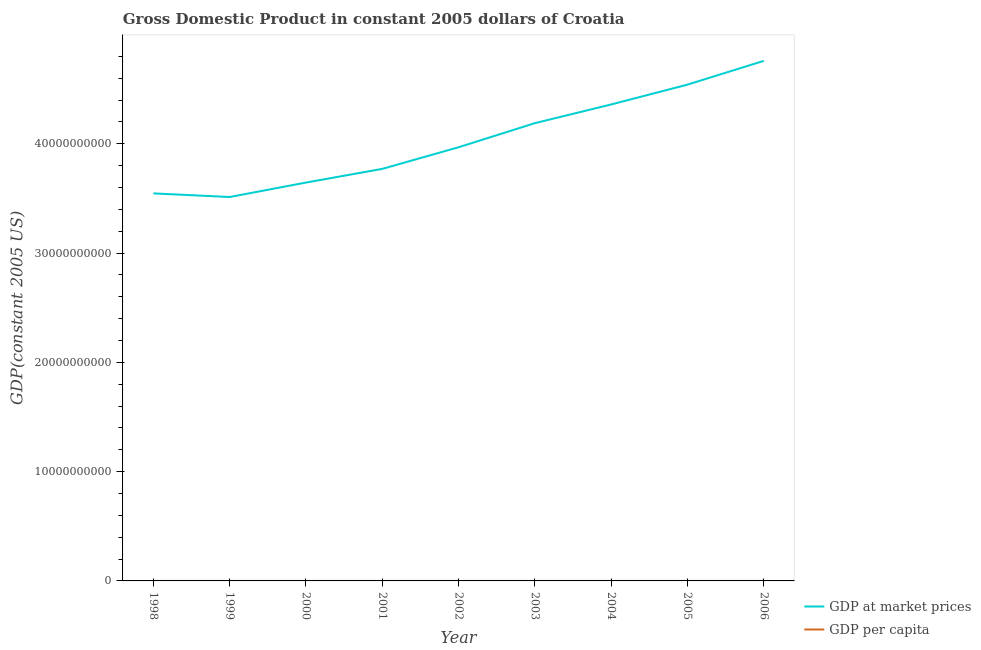What is the gdp per capita in 1999?
Your answer should be compact. 7714.29. Across all years, what is the maximum gdp at market prices?
Your answer should be very brief. 4.76e+1. Across all years, what is the minimum gdp per capita?
Your response must be concise. 7714.29. In which year was the gdp at market prices maximum?
Provide a succinct answer. 2006. What is the total gdp at market prices in the graph?
Ensure brevity in your answer.  3.63e+11. What is the difference between the gdp at market prices in 1998 and that in 2006?
Offer a terse response. -1.21e+1. What is the difference between the gdp at market prices in 2003 and the gdp per capita in 2005?
Your answer should be very brief. 4.19e+1. What is the average gdp at market prices per year?
Offer a terse response. 4.03e+1. In the year 1998, what is the difference between the gdp at market prices and gdp per capita?
Your response must be concise. 3.55e+1. What is the ratio of the gdp per capita in 2002 to that in 2005?
Provide a short and direct response. 0.87. Is the gdp per capita in 1998 less than that in 1999?
Keep it short and to the point. No. What is the difference between the highest and the second highest gdp per capita?
Give a very brief answer. 494.07. What is the difference between the highest and the lowest gdp at market prices?
Your answer should be very brief. 1.25e+1. In how many years, is the gdp at market prices greater than the average gdp at market prices taken over all years?
Make the answer very short. 4. Is the gdp per capita strictly greater than the gdp at market prices over the years?
Offer a very short reply. No. Is the gdp per capita strictly less than the gdp at market prices over the years?
Ensure brevity in your answer.  Yes. What is the difference between two consecutive major ticks on the Y-axis?
Your response must be concise. 1.00e+1. Are the values on the major ticks of Y-axis written in scientific E-notation?
Make the answer very short. No. Where does the legend appear in the graph?
Make the answer very short. Bottom right. What is the title of the graph?
Keep it short and to the point. Gross Domestic Product in constant 2005 dollars of Croatia. Does "Forest" appear as one of the legend labels in the graph?
Your response must be concise. No. What is the label or title of the X-axis?
Provide a short and direct response. Year. What is the label or title of the Y-axis?
Ensure brevity in your answer.  GDP(constant 2005 US). What is the GDP(constant 2005 US) in GDP at market prices in 1998?
Your answer should be compact. 3.55e+1. What is the GDP(constant 2005 US) of GDP per capita in 1998?
Give a very brief answer. 7878.83. What is the GDP(constant 2005 US) of GDP at market prices in 1999?
Offer a terse response. 3.51e+1. What is the GDP(constant 2005 US) of GDP per capita in 1999?
Your response must be concise. 7714.29. What is the GDP(constant 2005 US) of GDP at market prices in 2000?
Provide a short and direct response. 3.65e+1. What is the GDP(constant 2005 US) in GDP per capita in 2000?
Your answer should be compact. 8236.43. What is the GDP(constant 2005 US) in GDP at market prices in 2001?
Provide a short and direct response. 3.77e+1. What is the GDP(constant 2005 US) of GDP per capita in 2001?
Offer a very short reply. 8492.44. What is the GDP(constant 2005 US) of GDP at market prices in 2002?
Your answer should be very brief. 3.97e+1. What is the GDP(constant 2005 US) in GDP per capita in 2002?
Provide a short and direct response. 8937.99. What is the GDP(constant 2005 US) in GDP at market prices in 2003?
Provide a short and direct response. 4.19e+1. What is the GDP(constant 2005 US) of GDP per capita in 2003?
Make the answer very short. 9434.76. What is the GDP(constant 2005 US) in GDP at market prices in 2004?
Your answer should be very brief. 4.36e+1. What is the GDP(constant 2005 US) in GDP per capita in 2004?
Offer a terse response. 9822.17. What is the GDP(constant 2005 US) in GDP at market prices in 2005?
Offer a terse response. 4.54e+1. What is the GDP(constant 2005 US) in GDP per capita in 2005?
Offer a very short reply. 1.02e+04. What is the GDP(constant 2005 US) of GDP at market prices in 2006?
Your answer should be compact. 4.76e+1. What is the GDP(constant 2005 US) of GDP per capita in 2006?
Your answer should be compact. 1.07e+04. Across all years, what is the maximum GDP(constant 2005 US) in GDP at market prices?
Ensure brevity in your answer.  4.76e+1. Across all years, what is the maximum GDP(constant 2005 US) of GDP per capita?
Offer a very short reply. 1.07e+04. Across all years, what is the minimum GDP(constant 2005 US) of GDP at market prices?
Offer a terse response. 3.51e+1. Across all years, what is the minimum GDP(constant 2005 US) in GDP per capita?
Provide a succinct answer. 7714.29. What is the total GDP(constant 2005 US) of GDP at market prices in the graph?
Your response must be concise. 3.63e+11. What is the total GDP(constant 2005 US) of GDP per capita in the graph?
Offer a very short reply. 8.15e+04. What is the difference between the GDP(constant 2005 US) in GDP at market prices in 1998 and that in 1999?
Offer a very short reply. 3.32e+08. What is the difference between the GDP(constant 2005 US) of GDP per capita in 1998 and that in 1999?
Your response must be concise. 164.54. What is the difference between the GDP(constant 2005 US) in GDP at market prices in 1998 and that in 2000?
Offer a very short reply. -9.92e+08. What is the difference between the GDP(constant 2005 US) of GDP per capita in 1998 and that in 2000?
Your answer should be compact. -357.59. What is the difference between the GDP(constant 2005 US) in GDP at market prices in 1998 and that in 2001?
Your answer should be very brief. -2.24e+09. What is the difference between the GDP(constant 2005 US) of GDP per capita in 1998 and that in 2001?
Offer a terse response. -613.6. What is the difference between the GDP(constant 2005 US) in GDP at market prices in 1998 and that in 2002?
Offer a very short reply. -4.22e+09. What is the difference between the GDP(constant 2005 US) of GDP per capita in 1998 and that in 2002?
Your answer should be very brief. -1059.16. What is the difference between the GDP(constant 2005 US) of GDP at market prices in 1998 and that in 2003?
Keep it short and to the point. -6.43e+09. What is the difference between the GDP(constant 2005 US) in GDP per capita in 1998 and that in 2003?
Your answer should be compact. -1555.92. What is the difference between the GDP(constant 2005 US) in GDP at market prices in 1998 and that in 2004?
Offer a terse response. -8.14e+09. What is the difference between the GDP(constant 2005 US) in GDP per capita in 1998 and that in 2004?
Ensure brevity in your answer.  -1943.34. What is the difference between the GDP(constant 2005 US) in GDP at market prices in 1998 and that in 2005?
Offer a very short reply. -9.95e+09. What is the difference between the GDP(constant 2005 US) in GDP per capita in 1998 and that in 2005?
Your answer should be very brief. -2345.41. What is the difference between the GDP(constant 2005 US) in GDP at market prices in 1998 and that in 2006?
Offer a very short reply. -1.21e+1. What is the difference between the GDP(constant 2005 US) of GDP per capita in 1998 and that in 2006?
Your answer should be compact. -2839.48. What is the difference between the GDP(constant 2005 US) of GDP at market prices in 1999 and that in 2000?
Provide a short and direct response. -1.32e+09. What is the difference between the GDP(constant 2005 US) of GDP per capita in 1999 and that in 2000?
Provide a short and direct response. -522.14. What is the difference between the GDP(constant 2005 US) in GDP at market prices in 1999 and that in 2001?
Your answer should be compact. -2.58e+09. What is the difference between the GDP(constant 2005 US) of GDP per capita in 1999 and that in 2001?
Ensure brevity in your answer.  -778.15. What is the difference between the GDP(constant 2005 US) in GDP at market prices in 1999 and that in 2002?
Your answer should be very brief. -4.55e+09. What is the difference between the GDP(constant 2005 US) in GDP per capita in 1999 and that in 2002?
Your response must be concise. -1223.7. What is the difference between the GDP(constant 2005 US) of GDP at market prices in 1999 and that in 2003?
Keep it short and to the point. -6.76e+09. What is the difference between the GDP(constant 2005 US) in GDP per capita in 1999 and that in 2003?
Your answer should be compact. -1720.47. What is the difference between the GDP(constant 2005 US) in GDP at market prices in 1999 and that in 2004?
Make the answer very short. -8.47e+09. What is the difference between the GDP(constant 2005 US) of GDP per capita in 1999 and that in 2004?
Keep it short and to the point. -2107.88. What is the difference between the GDP(constant 2005 US) of GDP at market prices in 1999 and that in 2005?
Provide a short and direct response. -1.03e+1. What is the difference between the GDP(constant 2005 US) in GDP per capita in 1999 and that in 2005?
Your response must be concise. -2509.95. What is the difference between the GDP(constant 2005 US) in GDP at market prices in 1999 and that in 2006?
Your answer should be compact. -1.25e+1. What is the difference between the GDP(constant 2005 US) in GDP per capita in 1999 and that in 2006?
Ensure brevity in your answer.  -3004.02. What is the difference between the GDP(constant 2005 US) in GDP at market prices in 2000 and that in 2001?
Your answer should be very brief. -1.25e+09. What is the difference between the GDP(constant 2005 US) in GDP per capita in 2000 and that in 2001?
Provide a succinct answer. -256.01. What is the difference between the GDP(constant 2005 US) in GDP at market prices in 2000 and that in 2002?
Your response must be concise. -3.23e+09. What is the difference between the GDP(constant 2005 US) of GDP per capita in 2000 and that in 2002?
Keep it short and to the point. -701.56. What is the difference between the GDP(constant 2005 US) in GDP at market prices in 2000 and that in 2003?
Provide a succinct answer. -5.44e+09. What is the difference between the GDP(constant 2005 US) of GDP per capita in 2000 and that in 2003?
Your answer should be compact. -1198.33. What is the difference between the GDP(constant 2005 US) in GDP at market prices in 2000 and that in 2004?
Offer a terse response. -7.15e+09. What is the difference between the GDP(constant 2005 US) of GDP per capita in 2000 and that in 2004?
Keep it short and to the point. -1585.74. What is the difference between the GDP(constant 2005 US) in GDP at market prices in 2000 and that in 2005?
Give a very brief answer. -8.96e+09. What is the difference between the GDP(constant 2005 US) in GDP per capita in 2000 and that in 2005?
Give a very brief answer. -1987.81. What is the difference between the GDP(constant 2005 US) of GDP at market prices in 2000 and that in 2006?
Ensure brevity in your answer.  -1.11e+1. What is the difference between the GDP(constant 2005 US) in GDP per capita in 2000 and that in 2006?
Provide a succinct answer. -2481.88. What is the difference between the GDP(constant 2005 US) of GDP at market prices in 2001 and that in 2002?
Offer a terse response. -1.98e+09. What is the difference between the GDP(constant 2005 US) of GDP per capita in 2001 and that in 2002?
Provide a succinct answer. -445.55. What is the difference between the GDP(constant 2005 US) of GDP at market prices in 2001 and that in 2003?
Provide a short and direct response. -4.18e+09. What is the difference between the GDP(constant 2005 US) in GDP per capita in 2001 and that in 2003?
Your answer should be very brief. -942.32. What is the difference between the GDP(constant 2005 US) of GDP at market prices in 2001 and that in 2004?
Ensure brevity in your answer.  -5.89e+09. What is the difference between the GDP(constant 2005 US) of GDP per capita in 2001 and that in 2004?
Make the answer very short. -1329.73. What is the difference between the GDP(constant 2005 US) of GDP at market prices in 2001 and that in 2005?
Ensure brevity in your answer.  -7.71e+09. What is the difference between the GDP(constant 2005 US) of GDP per capita in 2001 and that in 2005?
Provide a succinct answer. -1731.8. What is the difference between the GDP(constant 2005 US) in GDP at market prices in 2001 and that in 2006?
Provide a short and direct response. -9.88e+09. What is the difference between the GDP(constant 2005 US) in GDP per capita in 2001 and that in 2006?
Provide a succinct answer. -2225.87. What is the difference between the GDP(constant 2005 US) of GDP at market prices in 2002 and that in 2003?
Ensure brevity in your answer.  -2.21e+09. What is the difference between the GDP(constant 2005 US) in GDP per capita in 2002 and that in 2003?
Provide a short and direct response. -496.77. What is the difference between the GDP(constant 2005 US) of GDP at market prices in 2002 and that in 2004?
Your response must be concise. -3.92e+09. What is the difference between the GDP(constant 2005 US) of GDP per capita in 2002 and that in 2004?
Provide a short and direct response. -884.18. What is the difference between the GDP(constant 2005 US) in GDP at market prices in 2002 and that in 2005?
Your answer should be compact. -5.73e+09. What is the difference between the GDP(constant 2005 US) in GDP per capita in 2002 and that in 2005?
Ensure brevity in your answer.  -1286.25. What is the difference between the GDP(constant 2005 US) of GDP at market prices in 2002 and that in 2006?
Your answer should be very brief. -7.90e+09. What is the difference between the GDP(constant 2005 US) in GDP per capita in 2002 and that in 2006?
Your response must be concise. -1780.32. What is the difference between the GDP(constant 2005 US) in GDP at market prices in 2003 and that in 2004?
Your answer should be very brief. -1.71e+09. What is the difference between the GDP(constant 2005 US) in GDP per capita in 2003 and that in 2004?
Your response must be concise. -387.42. What is the difference between the GDP(constant 2005 US) in GDP at market prices in 2003 and that in 2005?
Make the answer very short. -3.53e+09. What is the difference between the GDP(constant 2005 US) of GDP per capita in 2003 and that in 2005?
Your answer should be compact. -789.49. What is the difference between the GDP(constant 2005 US) of GDP at market prices in 2003 and that in 2006?
Make the answer very short. -5.70e+09. What is the difference between the GDP(constant 2005 US) in GDP per capita in 2003 and that in 2006?
Your answer should be compact. -1283.55. What is the difference between the GDP(constant 2005 US) of GDP at market prices in 2004 and that in 2005?
Your response must be concise. -1.82e+09. What is the difference between the GDP(constant 2005 US) of GDP per capita in 2004 and that in 2005?
Provide a short and direct response. -402.07. What is the difference between the GDP(constant 2005 US) in GDP at market prices in 2004 and that in 2006?
Your answer should be very brief. -3.99e+09. What is the difference between the GDP(constant 2005 US) in GDP per capita in 2004 and that in 2006?
Provide a short and direct response. -896.14. What is the difference between the GDP(constant 2005 US) of GDP at market prices in 2005 and that in 2006?
Your response must be concise. -2.17e+09. What is the difference between the GDP(constant 2005 US) in GDP per capita in 2005 and that in 2006?
Your response must be concise. -494.07. What is the difference between the GDP(constant 2005 US) of GDP at market prices in 1998 and the GDP(constant 2005 US) of GDP per capita in 1999?
Offer a very short reply. 3.55e+1. What is the difference between the GDP(constant 2005 US) of GDP at market prices in 1998 and the GDP(constant 2005 US) of GDP per capita in 2000?
Offer a very short reply. 3.55e+1. What is the difference between the GDP(constant 2005 US) of GDP at market prices in 1998 and the GDP(constant 2005 US) of GDP per capita in 2001?
Your answer should be compact. 3.55e+1. What is the difference between the GDP(constant 2005 US) in GDP at market prices in 1998 and the GDP(constant 2005 US) in GDP per capita in 2002?
Give a very brief answer. 3.55e+1. What is the difference between the GDP(constant 2005 US) of GDP at market prices in 1998 and the GDP(constant 2005 US) of GDP per capita in 2003?
Offer a very short reply. 3.55e+1. What is the difference between the GDP(constant 2005 US) of GDP at market prices in 1998 and the GDP(constant 2005 US) of GDP per capita in 2004?
Offer a very short reply. 3.55e+1. What is the difference between the GDP(constant 2005 US) in GDP at market prices in 1998 and the GDP(constant 2005 US) in GDP per capita in 2005?
Offer a very short reply. 3.55e+1. What is the difference between the GDP(constant 2005 US) in GDP at market prices in 1998 and the GDP(constant 2005 US) in GDP per capita in 2006?
Your answer should be compact. 3.55e+1. What is the difference between the GDP(constant 2005 US) in GDP at market prices in 1999 and the GDP(constant 2005 US) in GDP per capita in 2000?
Provide a succinct answer. 3.51e+1. What is the difference between the GDP(constant 2005 US) of GDP at market prices in 1999 and the GDP(constant 2005 US) of GDP per capita in 2001?
Your response must be concise. 3.51e+1. What is the difference between the GDP(constant 2005 US) in GDP at market prices in 1999 and the GDP(constant 2005 US) in GDP per capita in 2002?
Offer a very short reply. 3.51e+1. What is the difference between the GDP(constant 2005 US) in GDP at market prices in 1999 and the GDP(constant 2005 US) in GDP per capita in 2003?
Give a very brief answer. 3.51e+1. What is the difference between the GDP(constant 2005 US) in GDP at market prices in 1999 and the GDP(constant 2005 US) in GDP per capita in 2004?
Offer a terse response. 3.51e+1. What is the difference between the GDP(constant 2005 US) of GDP at market prices in 1999 and the GDP(constant 2005 US) of GDP per capita in 2005?
Provide a short and direct response. 3.51e+1. What is the difference between the GDP(constant 2005 US) of GDP at market prices in 1999 and the GDP(constant 2005 US) of GDP per capita in 2006?
Make the answer very short. 3.51e+1. What is the difference between the GDP(constant 2005 US) in GDP at market prices in 2000 and the GDP(constant 2005 US) in GDP per capita in 2001?
Provide a short and direct response. 3.65e+1. What is the difference between the GDP(constant 2005 US) in GDP at market prices in 2000 and the GDP(constant 2005 US) in GDP per capita in 2002?
Ensure brevity in your answer.  3.65e+1. What is the difference between the GDP(constant 2005 US) in GDP at market prices in 2000 and the GDP(constant 2005 US) in GDP per capita in 2003?
Provide a succinct answer. 3.65e+1. What is the difference between the GDP(constant 2005 US) of GDP at market prices in 2000 and the GDP(constant 2005 US) of GDP per capita in 2004?
Keep it short and to the point. 3.65e+1. What is the difference between the GDP(constant 2005 US) in GDP at market prices in 2000 and the GDP(constant 2005 US) in GDP per capita in 2005?
Make the answer very short. 3.65e+1. What is the difference between the GDP(constant 2005 US) of GDP at market prices in 2000 and the GDP(constant 2005 US) of GDP per capita in 2006?
Give a very brief answer. 3.65e+1. What is the difference between the GDP(constant 2005 US) of GDP at market prices in 2001 and the GDP(constant 2005 US) of GDP per capita in 2002?
Your answer should be compact. 3.77e+1. What is the difference between the GDP(constant 2005 US) in GDP at market prices in 2001 and the GDP(constant 2005 US) in GDP per capita in 2003?
Your answer should be compact. 3.77e+1. What is the difference between the GDP(constant 2005 US) of GDP at market prices in 2001 and the GDP(constant 2005 US) of GDP per capita in 2004?
Your response must be concise. 3.77e+1. What is the difference between the GDP(constant 2005 US) of GDP at market prices in 2001 and the GDP(constant 2005 US) of GDP per capita in 2005?
Keep it short and to the point. 3.77e+1. What is the difference between the GDP(constant 2005 US) in GDP at market prices in 2001 and the GDP(constant 2005 US) in GDP per capita in 2006?
Keep it short and to the point. 3.77e+1. What is the difference between the GDP(constant 2005 US) in GDP at market prices in 2002 and the GDP(constant 2005 US) in GDP per capita in 2003?
Offer a terse response. 3.97e+1. What is the difference between the GDP(constant 2005 US) in GDP at market prices in 2002 and the GDP(constant 2005 US) in GDP per capita in 2004?
Your answer should be compact. 3.97e+1. What is the difference between the GDP(constant 2005 US) in GDP at market prices in 2002 and the GDP(constant 2005 US) in GDP per capita in 2005?
Provide a short and direct response. 3.97e+1. What is the difference between the GDP(constant 2005 US) in GDP at market prices in 2002 and the GDP(constant 2005 US) in GDP per capita in 2006?
Make the answer very short. 3.97e+1. What is the difference between the GDP(constant 2005 US) in GDP at market prices in 2003 and the GDP(constant 2005 US) in GDP per capita in 2004?
Provide a succinct answer. 4.19e+1. What is the difference between the GDP(constant 2005 US) of GDP at market prices in 2003 and the GDP(constant 2005 US) of GDP per capita in 2005?
Offer a very short reply. 4.19e+1. What is the difference between the GDP(constant 2005 US) in GDP at market prices in 2003 and the GDP(constant 2005 US) in GDP per capita in 2006?
Give a very brief answer. 4.19e+1. What is the difference between the GDP(constant 2005 US) in GDP at market prices in 2004 and the GDP(constant 2005 US) in GDP per capita in 2005?
Offer a terse response. 4.36e+1. What is the difference between the GDP(constant 2005 US) in GDP at market prices in 2004 and the GDP(constant 2005 US) in GDP per capita in 2006?
Your answer should be very brief. 4.36e+1. What is the difference between the GDP(constant 2005 US) of GDP at market prices in 2005 and the GDP(constant 2005 US) of GDP per capita in 2006?
Make the answer very short. 4.54e+1. What is the average GDP(constant 2005 US) of GDP at market prices per year?
Offer a very short reply. 4.03e+1. What is the average GDP(constant 2005 US) of GDP per capita per year?
Make the answer very short. 9051.05. In the year 1998, what is the difference between the GDP(constant 2005 US) of GDP at market prices and GDP(constant 2005 US) of GDP per capita?
Make the answer very short. 3.55e+1. In the year 1999, what is the difference between the GDP(constant 2005 US) of GDP at market prices and GDP(constant 2005 US) of GDP per capita?
Your response must be concise. 3.51e+1. In the year 2000, what is the difference between the GDP(constant 2005 US) in GDP at market prices and GDP(constant 2005 US) in GDP per capita?
Offer a very short reply. 3.65e+1. In the year 2001, what is the difference between the GDP(constant 2005 US) of GDP at market prices and GDP(constant 2005 US) of GDP per capita?
Ensure brevity in your answer.  3.77e+1. In the year 2002, what is the difference between the GDP(constant 2005 US) of GDP at market prices and GDP(constant 2005 US) of GDP per capita?
Your answer should be very brief. 3.97e+1. In the year 2003, what is the difference between the GDP(constant 2005 US) of GDP at market prices and GDP(constant 2005 US) of GDP per capita?
Your answer should be very brief. 4.19e+1. In the year 2004, what is the difference between the GDP(constant 2005 US) in GDP at market prices and GDP(constant 2005 US) in GDP per capita?
Your answer should be compact. 4.36e+1. In the year 2005, what is the difference between the GDP(constant 2005 US) of GDP at market prices and GDP(constant 2005 US) of GDP per capita?
Make the answer very short. 4.54e+1. In the year 2006, what is the difference between the GDP(constant 2005 US) of GDP at market prices and GDP(constant 2005 US) of GDP per capita?
Keep it short and to the point. 4.76e+1. What is the ratio of the GDP(constant 2005 US) in GDP at market prices in 1998 to that in 1999?
Keep it short and to the point. 1.01. What is the ratio of the GDP(constant 2005 US) in GDP per capita in 1998 to that in 1999?
Provide a short and direct response. 1.02. What is the ratio of the GDP(constant 2005 US) of GDP at market prices in 1998 to that in 2000?
Provide a succinct answer. 0.97. What is the ratio of the GDP(constant 2005 US) of GDP per capita in 1998 to that in 2000?
Make the answer very short. 0.96. What is the ratio of the GDP(constant 2005 US) of GDP at market prices in 1998 to that in 2001?
Offer a very short reply. 0.94. What is the ratio of the GDP(constant 2005 US) in GDP per capita in 1998 to that in 2001?
Your answer should be compact. 0.93. What is the ratio of the GDP(constant 2005 US) of GDP at market prices in 1998 to that in 2002?
Keep it short and to the point. 0.89. What is the ratio of the GDP(constant 2005 US) in GDP per capita in 1998 to that in 2002?
Make the answer very short. 0.88. What is the ratio of the GDP(constant 2005 US) of GDP at market prices in 1998 to that in 2003?
Offer a terse response. 0.85. What is the ratio of the GDP(constant 2005 US) of GDP per capita in 1998 to that in 2003?
Ensure brevity in your answer.  0.84. What is the ratio of the GDP(constant 2005 US) of GDP at market prices in 1998 to that in 2004?
Ensure brevity in your answer.  0.81. What is the ratio of the GDP(constant 2005 US) in GDP per capita in 1998 to that in 2004?
Offer a terse response. 0.8. What is the ratio of the GDP(constant 2005 US) in GDP at market prices in 1998 to that in 2005?
Give a very brief answer. 0.78. What is the ratio of the GDP(constant 2005 US) of GDP per capita in 1998 to that in 2005?
Make the answer very short. 0.77. What is the ratio of the GDP(constant 2005 US) in GDP at market prices in 1998 to that in 2006?
Offer a terse response. 0.75. What is the ratio of the GDP(constant 2005 US) in GDP per capita in 1998 to that in 2006?
Provide a succinct answer. 0.74. What is the ratio of the GDP(constant 2005 US) in GDP at market prices in 1999 to that in 2000?
Your answer should be very brief. 0.96. What is the ratio of the GDP(constant 2005 US) in GDP per capita in 1999 to that in 2000?
Ensure brevity in your answer.  0.94. What is the ratio of the GDP(constant 2005 US) of GDP at market prices in 1999 to that in 2001?
Provide a short and direct response. 0.93. What is the ratio of the GDP(constant 2005 US) in GDP per capita in 1999 to that in 2001?
Provide a succinct answer. 0.91. What is the ratio of the GDP(constant 2005 US) in GDP at market prices in 1999 to that in 2002?
Provide a succinct answer. 0.89. What is the ratio of the GDP(constant 2005 US) in GDP per capita in 1999 to that in 2002?
Make the answer very short. 0.86. What is the ratio of the GDP(constant 2005 US) in GDP at market prices in 1999 to that in 2003?
Offer a terse response. 0.84. What is the ratio of the GDP(constant 2005 US) in GDP per capita in 1999 to that in 2003?
Make the answer very short. 0.82. What is the ratio of the GDP(constant 2005 US) in GDP at market prices in 1999 to that in 2004?
Offer a very short reply. 0.81. What is the ratio of the GDP(constant 2005 US) of GDP per capita in 1999 to that in 2004?
Your answer should be compact. 0.79. What is the ratio of the GDP(constant 2005 US) in GDP at market prices in 1999 to that in 2005?
Your answer should be very brief. 0.77. What is the ratio of the GDP(constant 2005 US) of GDP per capita in 1999 to that in 2005?
Provide a succinct answer. 0.75. What is the ratio of the GDP(constant 2005 US) in GDP at market prices in 1999 to that in 2006?
Offer a very short reply. 0.74. What is the ratio of the GDP(constant 2005 US) of GDP per capita in 1999 to that in 2006?
Keep it short and to the point. 0.72. What is the ratio of the GDP(constant 2005 US) in GDP at market prices in 2000 to that in 2001?
Offer a terse response. 0.97. What is the ratio of the GDP(constant 2005 US) of GDP per capita in 2000 to that in 2001?
Offer a very short reply. 0.97. What is the ratio of the GDP(constant 2005 US) in GDP at market prices in 2000 to that in 2002?
Your answer should be compact. 0.92. What is the ratio of the GDP(constant 2005 US) in GDP per capita in 2000 to that in 2002?
Your response must be concise. 0.92. What is the ratio of the GDP(constant 2005 US) of GDP at market prices in 2000 to that in 2003?
Your answer should be compact. 0.87. What is the ratio of the GDP(constant 2005 US) of GDP per capita in 2000 to that in 2003?
Your answer should be compact. 0.87. What is the ratio of the GDP(constant 2005 US) in GDP at market prices in 2000 to that in 2004?
Your response must be concise. 0.84. What is the ratio of the GDP(constant 2005 US) of GDP per capita in 2000 to that in 2004?
Your answer should be very brief. 0.84. What is the ratio of the GDP(constant 2005 US) of GDP at market prices in 2000 to that in 2005?
Your response must be concise. 0.8. What is the ratio of the GDP(constant 2005 US) of GDP per capita in 2000 to that in 2005?
Keep it short and to the point. 0.81. What is the ratio of the GDP(constant 2005 US) of GDP at market prices in 2000 to that in 2006?
Make the answer very short. 0.77. What is the ratio of the GDP(constant 2005 US) in GDP per capita in 2000 to that in 2006?
Offer a terse response. 0.77. What is the ratio of the GDP(constant 2005 US) in GDP at market prices in 2001 to that in 2002?
Offer a terse response. 0.95. What is the ratio of the GDP(constant 2005 US) of GDP per capita in 2001 to that in 2002?
Offer a terse response. 0.95. What is the ratio of the GDP(constant 2005 US) in GDP at market prices in 2001 to that in 2003?
Provide a short and direct response. 0.9. What is the ratio of the GDP(constant 2005 US) of GDP per capita in 2001 to that in 2003?
Give a very brief answer. 0.9. What is the ratio of the GDP(constant 2005 US) in GDP at market prices in 2001 to that in 2004?
Offer a very short reply. 0.86. What is the ratio of the GDP(constant 2005 US) of GDP per capita in 2001 to that in 2004?
Give a very brief answer. 0.86. What is the ratio of the GDP(constant 2005 US) of GDP at market prices in 2001 to that in 2005?
Provide a short and direct response. 0.83. What is the ratio of the GDP(constant 2005 US) in GDP per capita in 2001 to that in 2005?
Your response must be concise. 0.83. What is the ratio of the GDP(constant 2005 US) of GDP at market prices in 2001 to that in 2006?
Provide a succinct answer. 0.79. What is the ratio of the GDP(constant 2005 US) of GDP per capita in 2001 to that in 2006?
Make the answer very short. 0.79. What is the ratio of the GDP(constant 2005 US) in GDP at market prices in 2002 to that in 2003?
Offer a terse response. 0.95. What is the ratio of the GDP(constant 2005 US) in GDP per capita in 2002 to that in 2003?
Give a very brief answer. 0.95. What is the ratio of the GDP(constant 2005 US) of GDP at market prices in 2002 to that in 2004?
Ensure brevity in your answer.  0.91. What is the ratio of the GDP(constant 2005 US) in GDP per capita in 2002 to that in 2004?
Keep it short and to the point. 0.91. What is the ratio of the GDP(constant 2005 US) in GDP at market prices in 2002 to that in 2005?
Your answer should be very brief. 0.87. What is the ratio of the GDP(constant 2005 US) in GDP per capita in 2002 to that in 2005?
Keep it short and to the point. 0.87. What is the ratio of the GDP(constant 2005 US) of GDP at market prices in 2002 to that in 2006?
Provide a succinct answer. 0.83. What is the ratio of the GDP(constant 2005 US) in GDP per capita in 2002 to that in 2006?
Ensure brevity in your answer.  0.83. What is the ratio of the GDP(constant 2005 US) in GDP at market prices in 2003 to that in 2004?
Ensure brevity in your answer.  0.96. What is the ratio of the GDP(constant 2005 US) of GDP per capita in 2003 to that in 2004?
Your answer should be compact. 0.96. What is the ratio of the GDP(constant 2005 US) of GDP at market prices in 2003 to that in 2005?
Provide a short and direct response. 0.92. What is the ratio of the GDP(constant 2005 US) in GDP per capita in 2003 to that in 2005?
Offer a very short reply. 0.92. What is the ratio of the GDP(constant 2005 US) of GDP at market prices in 2003 to that in 2006?
Ensure brevity in your answer.  0.88. What is the ratio of the GDP(constant 2005 US) of GDP per capita in 2003 to that in 2006?
Provide a short and direct response. 0.88. What is the ratio of the GDP(constant 2005 US) of GDP at market prices in 2004 to that in 2005?
Make the answer very short. 0.96. What is the ratio of the GDP(constant 2005 US) of GDP per capita in 2004 to that in 2005?
Ensure brevity in your answer.  0.96. What is the ratio of the GDP(constant 2005 US) of GDP at market prices in 2004 to that in 2006?
Ensure brevity in your answer.  0.92. What is the ratio of the GDP(constant 2005 US) of GDP per capita in 2004 to that in 2006?
Give a very brief answer. 0.92. What is the ratio of the GDP(constant 2005 US) in GDP at market prices in 2005 to that in 2006?
Make the answer very short. 0.95. What is the ratio of the GDP(constant 2005 US) of GDP per capita in 2005 to that in 2006?
Your response must be concise. 0.95. What is the difference between the highest and the second highest GDP(constant 2005 US) of GDP at market prices?
Give a very brief answer. 2.17e+09. What is the difference between the highest and the second highest GDP(constant 2005 US) of GDP per capita?
Give a very brief answer. 494.07. What is the difference between the highest and the lowest GDP(constant 2005 US) of GDP at market prices?
Your response must be concise. 1.25e+1. What is the difference between the highest and the lowest GDP(constant 2005 US) of GDP per capita?
Offer a terse response. 3004.02. 